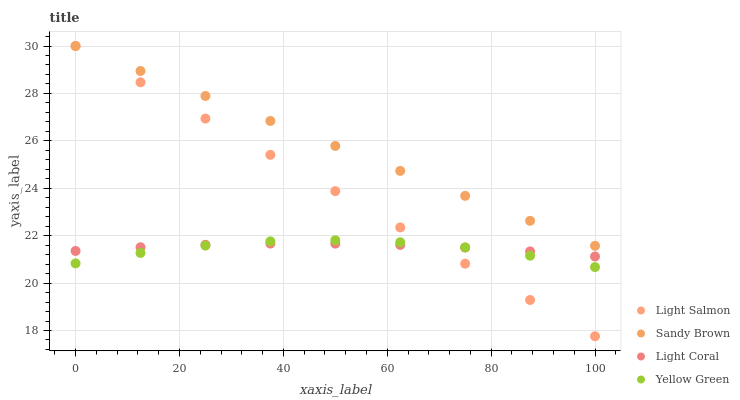Does Yellow Green have the minimum area under the curve?
Answer yes or no. Yes. Does Sandy Brown have the maximum area under the curve?
Answer yes or no. Yes. Does Light Salmon have the minimum area under the curve?
Answer yes or no. No. Does Light Salmon have the maximum area under the curve?
Answer yes or no. No. Is Light Salmon the smoothest?
Answer yes or no. Yes. Is Yellow Green the roughest?
Answer yes or no. Yes. Is Yellow Green the smoothest?
Answer yes or no. No. Is Sandy Brown the roughest?
Answer yes or no. No. Does Light Salmon have the lowest value?
Answer yes or no. Yes. Does Sandy Brown have the lowest value?
Answer yes or no. No. Does Sandy Brown have the highest value?
Answer yes or no. Yes. Does Yellow Green have the highest value?
Answer yes or no. No. Is Yellow Green less than Sandy Brown?
Answer yes or no. Yes. Is Sandy Brown greater than Yellow Green?
Answer yes or no. Yes. Does Light Coral intersect Light Salmon?
Answer yes or no. Yes. Is Light Coral less than Light Salmon?
Answer yes or no. No. Is Light Coral greater than Light Salmon?
Answer yes or no. No. Does Yellow Green intersect Sandy Brown?
Answer yes or no. No. 